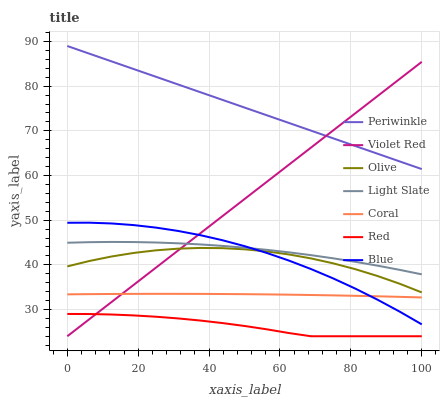Does Red have the minimum area under the curve?
Answer yes or no. Yes. Does Periwinkle have the maximum area under the curve?
Answer yes or no. Yes. Does Violet Red have the minimum area under the curve?
Answer yes or no. No. Does Violet Red have the maximum area under the curve?
Answer yes or no. No. Is Violet Red the smoothest?
Answer yes or no. Yes. Is Olive the roughest?
Answer yes or no. Yes. Is Light Slate the smoothest?
Answer yes or no. No. Is Light Slate the roughest?
Answer yes or no. No. Does Violet Red have the lowest value?
Answer yes or no. Yes. Does Light Slate have the lowest value?
Answer yes or no. No. Does Periwinkle have the highest value?
Answer yes or no. Yes. Does Violet Red have the highest value?
Answer yes or no. No. Is Light Slate less than Periwinkle?
Answer yes or no. Yes. Is Periwinkle greater than Coral?
Answer yes or no. Yes. Does Blue intersect Violet Red?
Answer yes or no. Yes. Is Blue less than Violet Red?
Answer yes or no. No. Is Blue greater than Violet Red?
Answer yes or no. No. Does Light Slate intersect Periwinkle?
Answer yes or no. No. 